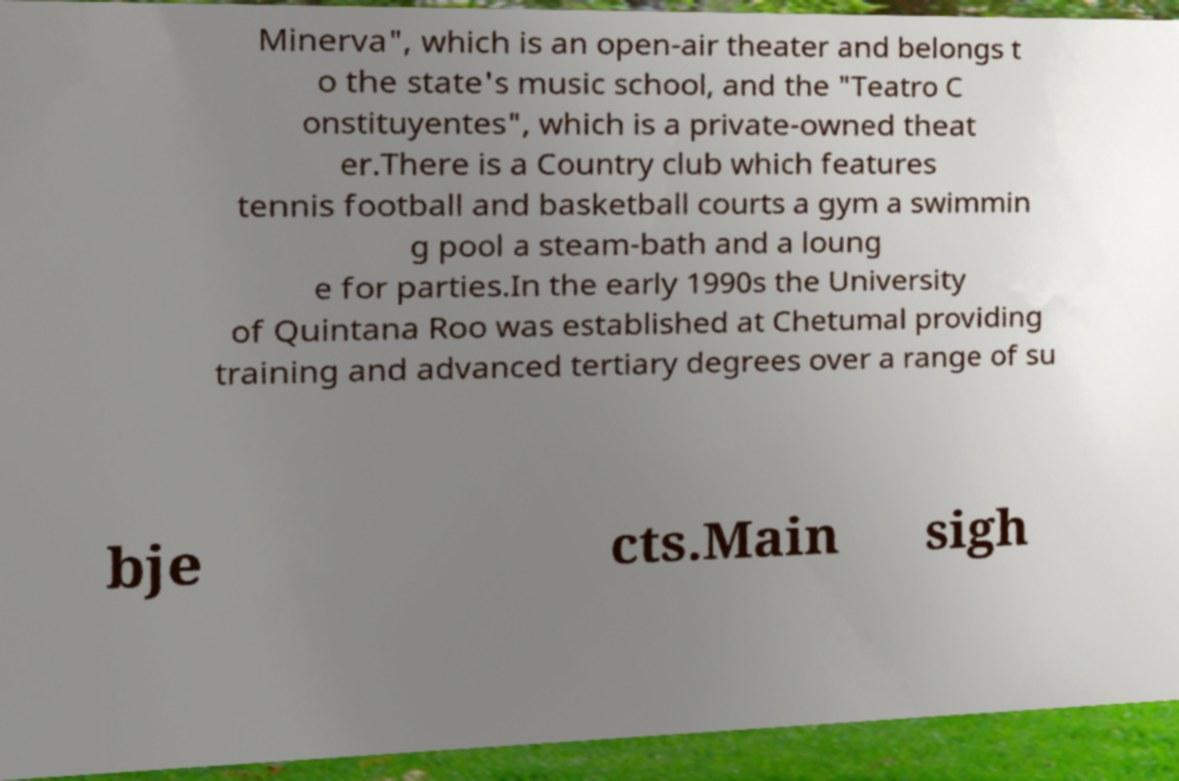Please identify and transcribe the text found in this image. Minerva", which is an open-air theater and belongs t o the state's music school, and the "Teatro C onstituyentes", which is a private-owned theat er.There is a Country club which features tennis football and basketball courts a gym a swimmin g pool a steam-bath and a loung e for parties.In the early 1990s the University of Quintana Roo was established at Chetumal providing training and advanced tertiary degrees over a range of su bje cts.Main sigh 